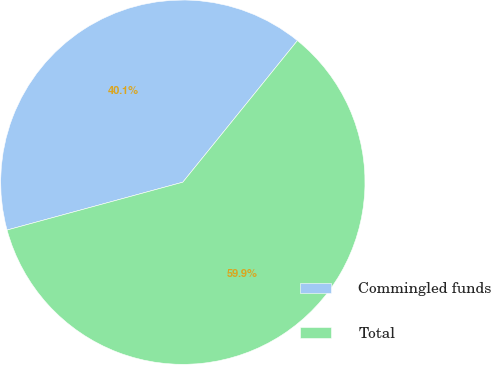Convert chart to OTSL. <chart><loc_0><loc_0><loc_500><loc_500><pie_chart><fcel>Commingled funds<fcel>Total<nl><fcel>40.06%<fcel>59.94%<nl></chart> 